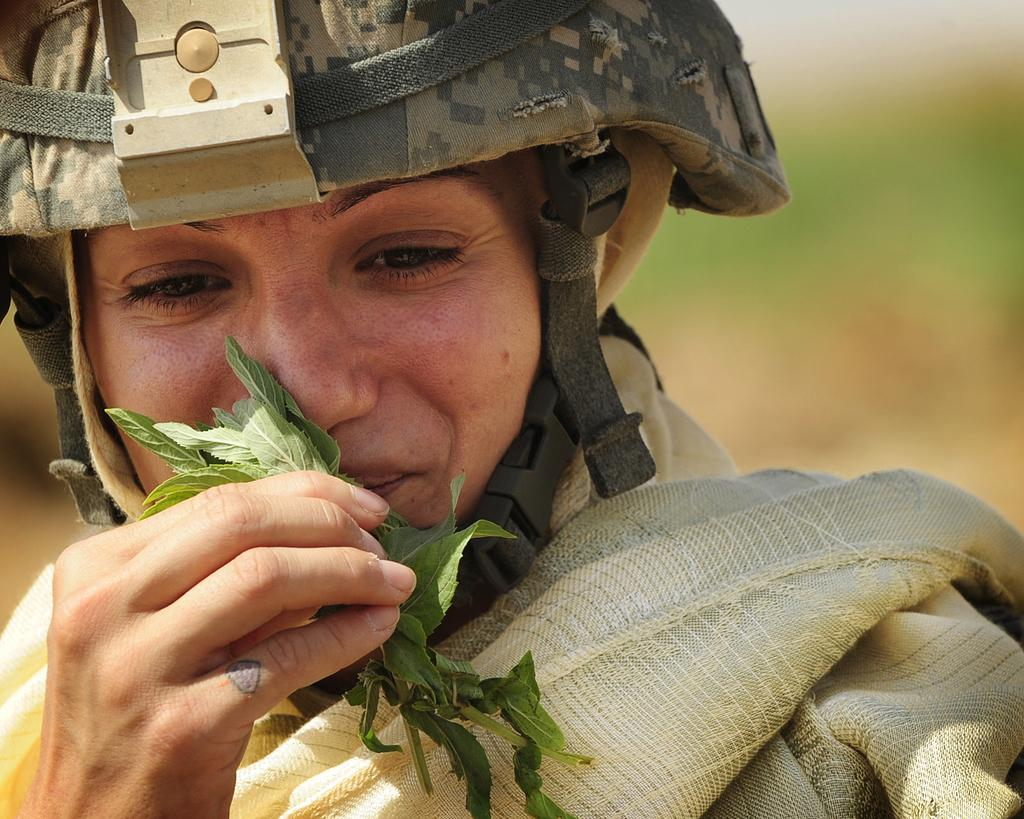Who is the main subject in the image? There is a woman in the image. What is the woman holding in the image? The woman is holding green color leaves. What protective gear is the woman wearing? The woman is wearing a helmet. How would you describe the image's background? The image is blurry in the background. What type of flag is the woman holding in the image? There is no flag present in the image; the woman is holding green color leaves. Who is the owner of the leaves in the image? The concept of ownership is not applicable in this context, as the leaves are not owned by anyone in the image. 